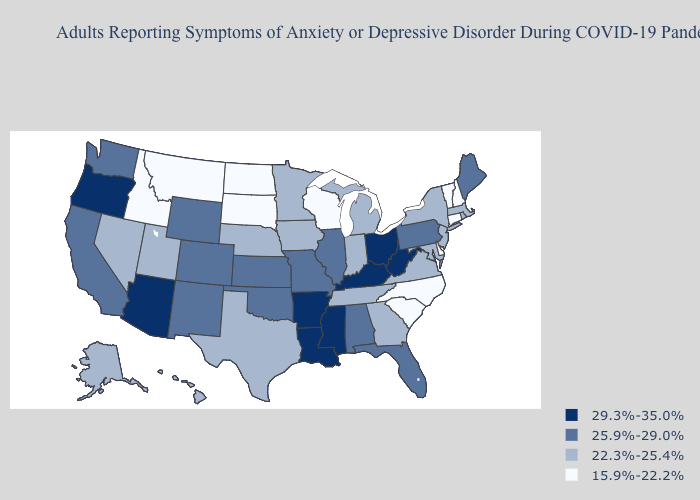What is the value of Alaska?
Concise answer only. 22.3%-25.4%. Among the states that border Alabama , does Mississippi have the lowest value?
Short answer required. No. Name the states that have a value in the range 29.3%-35.0%?
Be succinct. Arizona, Arkansas, Kentucky, Louisiana, Mississippi, Ohio, Oregon, West Virginia. What is the value of Maine?
Quick response, please. 25.9%-29.0%. Does Texas have a higher value than Connecticut?
Short answer required. Yes. Among the states that border Minnesota , does North Dakota have the highest value?
Answer briefly. No. What is the value of Missouri?
Give a very brief answer. 25.9%-29.0%. What is the highest value in the South ?
Give a very brief answer. 29.3%-35.0%. Which states have the lowest value in the USA?
Concise answer only. Connecticut, Delaware, Idaho, Montana, New Hampshire, North Carolina, North Dakota, South Carolina, South Dakota, Vermont, Wisconsin. Does Wisconsin have the highest value in the MidWest?
Give a very brief answer. No. What is the value of South Dakota?
Quick response, please. 15.9%-22.2%. Does New Mexico have the highest value in the West?
Be succinct. No. Does the map have missing data?
Keep it brief. No. Does Pennsylvania have the highest value in the Northeast?
Concise answer only. Yes. Among the states that border Virginia , does West Virginia have the highest value?
Give a very brief answer. Yes. 